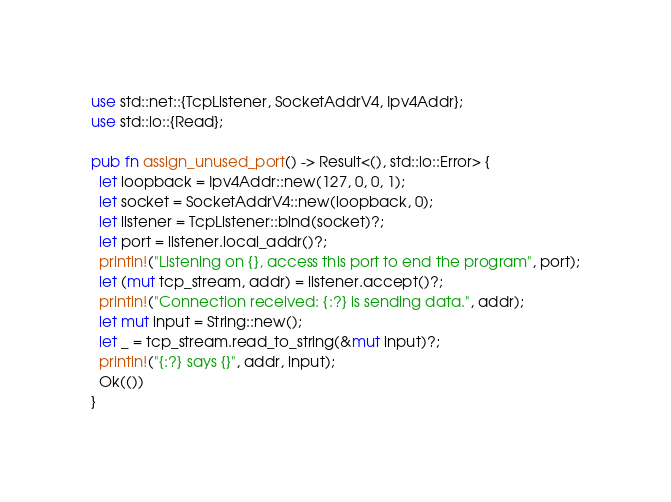Convert code to text. <code><loc_0><loc_0><loc_500><loc_500><_Rust_>use std::net::{TcpListener, SocketAddrV4, Ipv4Addr};
use std::io::{Read};

pub fn assign_unused_port() -> Result<(), std::io::Error> {
  let loopback = Ipv4Addr::new(127, 0, 0, 1);
  let socket = SocketAddrV4::new(loopback, 0);
  let listener = TcpListener::bind(socket)?;
  let port = listener.local_addr()?;
  println!("Listening on {}, access this port to end the program", port);
  let (mut tcp_stream, addr) = listener.accept()?;
  println!("Connection received: {:?} is sending data.", addr);
  let mut input = String::new();
  let _ = tcp_stream.read_to_string(&mut input)?;
  println!("{:?} says {}", addr, input);
  Ok(())
}</code> 